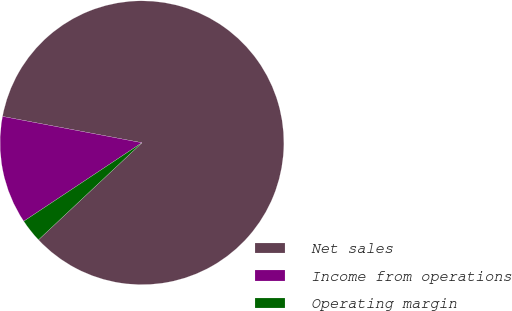<chart> <loc_0><loc_0><loc_500><loc_500><pie_chart><fcel>Net sales<fcel>Income from operations<fcel>Operating margin<nl><fcel>85.03%<fcel>12.3%<fcel>2.66%<nl></chart> 